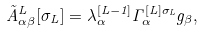Convert formula to latex. <formula><loc_0><loc_0><loc_500><loc_500>\tilde { A } ^ { L } _ { \alpha \beta } [ \sigma _ { L } ] = \lambda ^ { [ L - 1 ] } _ { \alpha } \Gamma ^ { [ L ] \sigma _ { L } } _ { \alpha } g _ { \beta } ,</formula> 